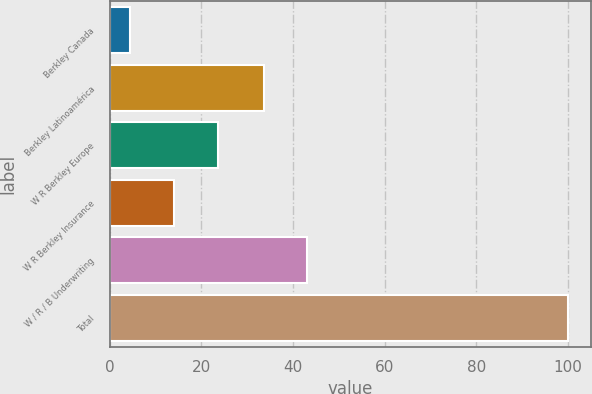Convert chart. <chart><loc_0><loc_0><loc_500><loc_500><bar_chart><fcel>Berkley Canada<fcel>Berkley Latinoamérica<fcel>W R Berkley Europe<fcel>W R Berkley Insurance<fcel>W / R / B Underwriting<fcel>Total<nl><fcel>4.5<fcel>33.6<fcel>23.6<fcel>14.05<fcel>43.15<fcel>100<nl></chart> 